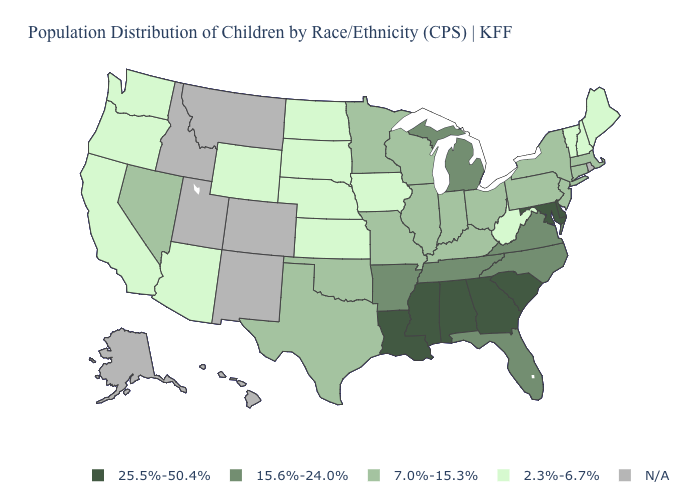Name the states that have a value in the range 25.5%-50.4%?
Keep it brief. Alabama, Delaware, Georgia, Louisiana, Maryland, Mississippi, South Carolina. What is the value of Ohio?
Quick response, please. 7.0%-15.3%. How many symbols are there in the legend?
Be succinct. 5. Name the states that have a value in the range 7.0%-15.3%?
Write a very short answer. Connecticut, Illinois, Indiana, Kentucky, Massachusetts, Minnesota, Missouri, Nevada, New Jersey, New York, Ohio, Oklahoma, Pennsylvania, Texas, Wisconsin. What is the lowest value in the West?
Short answer required. 2.3%-6.7%. Does Arkansas have the lowest value in the South?
Concise answer only. No. Among the states that border New York , which have the highest value?
Be succinct. Connecticut, Massachusetts, New Jersey, Pennsylvania. Which states have the highest value in the USA?
Keep it brief. Alabama, Delaware, Georgia, Louisiana, Maryland, Mississippi, South Carolina. Does Indiana have the highest value in the USA?
Write a very short answer. No. What is the value of Georgia?
Short answer required. 25.5%-50.4%. Name the states that have a value in the range N/A?
Short answer required. Alaska, Colorado, Hawaii, Idaho, Montana, New Mexico, Rhode Island, Utah. Does the map have missing data?
Be succinct. Yes. What is the lowest value in the USA?
Be succinct. 2.3%-6.7%. 